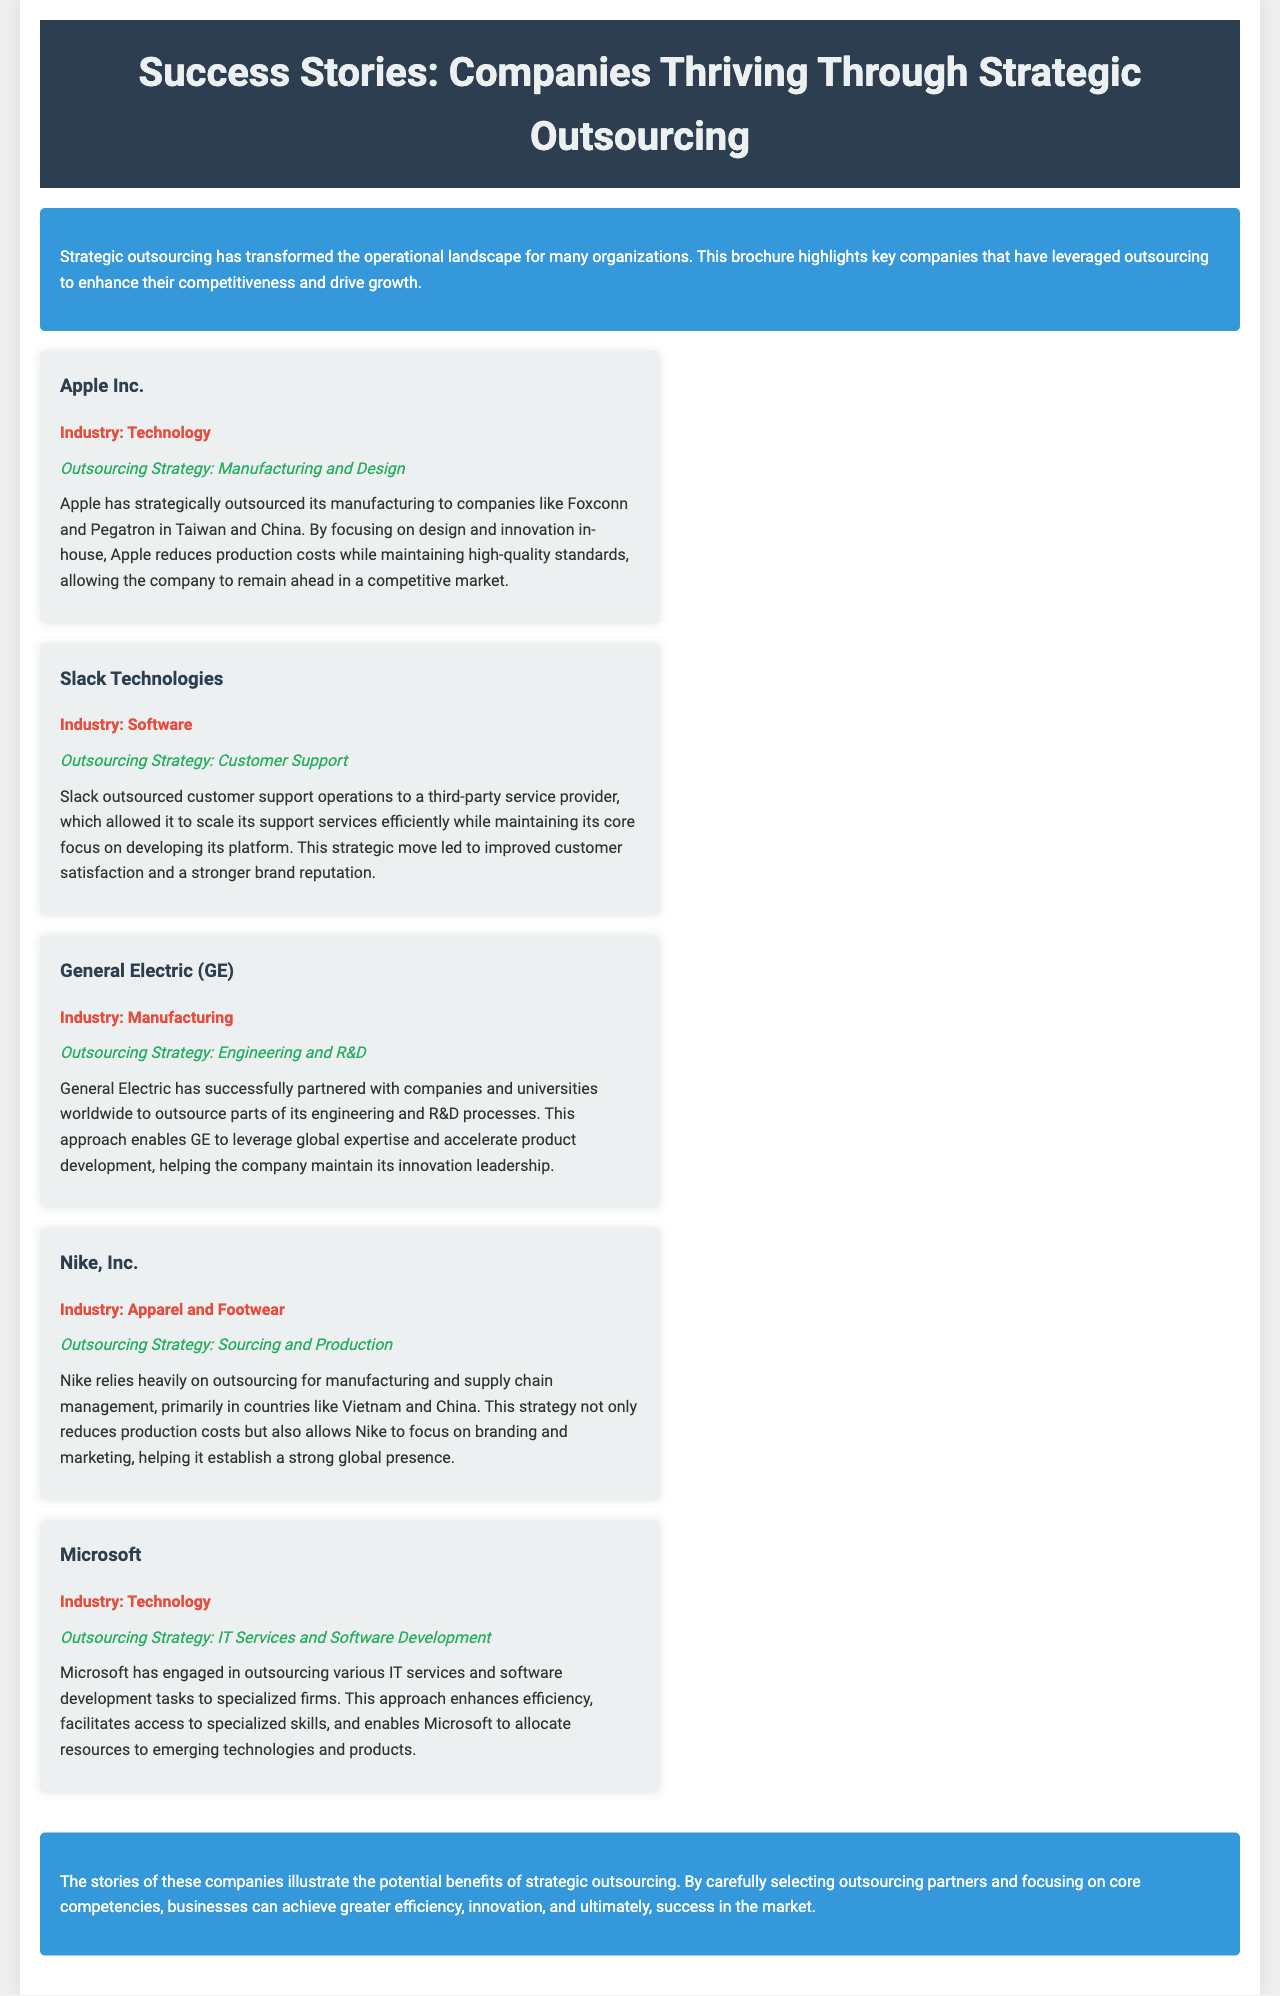What industry is Apple Inc. in? The industry of Apple Inc. is stated in the document as Technology.
Answer: Technology What is Slack Technologies' outsourcing strategy? The document specifies that Slack Technologies' outsourcing strategy is Customer Support.
Answer: Customer Support Who is Nike's primary manufacturing partner? The document mentions that Nike relies on manufacturing primarily in Vietnam and China.
Answer: Vietnam and China What benefit did General Electric gain from outsourcing? The document indicates that General Electric leveraged global expertise and accelerated product development through outsourcing.
Answer: Global expertise Which company outsourced its IT Services? According to the document, Microsoft is the company that outsourced its IT Services and Software Development.
Answer: Microsoft What is the role of outsourcing in Apple's operations? The document explains that outsourcing allows Apple to reduce production costs while maintaining high-quality standards by focusing on design and innovation in-house.
Answer: Reduce production costs What type of document is this? This document is a brochure that highlights success stories of companies thriving through strategic outsourcing.
Answer: Brochure Which company focuses on branding and marketing due to outsourcing? The document states that Nike focuses on branding and marketing because of its outsourcing strategy.
Answer: Nike, Inc 